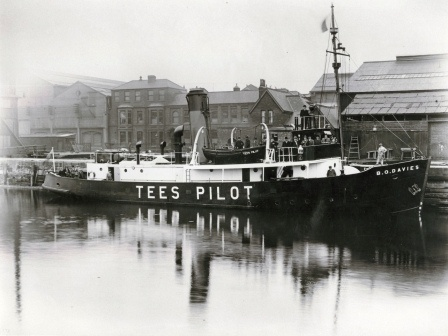Describe the objects in this image and their specific colors. I can see boat in lightgray, black, gray, and darkgray tones, people in lightgray, black, gray, and darkgray tones, people in lightgray, darkgray, gray, and black tones, people in lightgray, black, gray, and darkgray tones, and people in lightgray, darkgray, and gray tones in this image. 